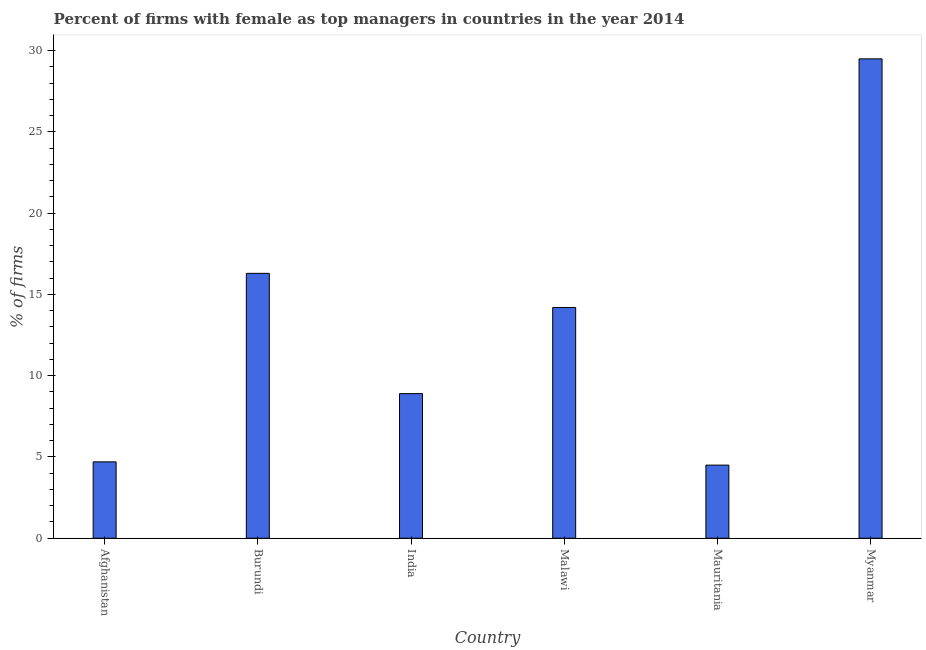What is the title of the graph?
Keep it short and to the point. Percent of firms with female as top managers in countries in the year 2014. What is the label or title of the Y-axis?
Provide a short and direct response. % of firms. What is the percentage of firms with female as top manager in Myanmar?
Your answer should be very brief. 29.5. Across all countries, what is the maximum percentage of firms with female as top manager?
Provide a short and direct response. 29.5. In which country was the percentage of firms with female as top manager maximum?
Your answer should be compact. Myanmar. In which country was the percentage of firms with female as top manager minimum?
Ensure brevity in your answer.  Mauritania. What is the sum of the percentage of firms with female as top manager?
Make the answer very short. 78.1. What is the average percentage of firms with female as top manager per country?
Offer a very short reply. 13.02. What is the median percentage of firms with female as top manager?
Make the answer very short. 11.55. What is the ratio of the percentage of firms with female as top manager in India to that in Malawi?
Give a very brief answer. 0.63. Is the percentage of firms with female as top manager in Burundi less than that in Myanmar?
Provide a short and direct response. Yes. Is the difference between the percentage of firms with female as top manager in India and Malawi greater than the difference between any two countries?
Your response must be concise. No. What is the difference between the highest and the second highest percentage of firms with female as top manager?
Offer a very short reply. 13.2. Is the sum of the percentage of firms with female as top manager in Afghanistan and Burundi greater than the maximum percentage of firms with female as top manager across all countries?
Provide a short and direct response. No. How many countries are there in the graph?
Your response must be concise. 6. What is the difference between two consecutive major ticks on the Y-axis?
Keep it short and to the point. 5. Are the values on the major ticks of Y-axis written in scientific E-notation?
Your answer should be very brief. No. What is the % of firms in Afghanistan?
Your answer should be compact. 4.7. What is the % of firms of Mauritania?
Offer a very short reply. 4.5. What is the % of firms in Myanmar?
Give a very brief answer. 29.5. What is the difference between the % of firms in Afghanistan and Burundi?
Make the answer very short. -11.6. What is the difference between the % of firms in Afghanistan and India?
Your response must be concise. -4.2. What is the difference between the % of firms in Afghanistan and Mauritania?
Offer a very short reply. 0.2. What is the difference between the % of firms in Afghanistan and Myanmar?
Ensure brevity in your answer.  -24.8. What is the difference between the % of firms in Burundi and India?
Give a very brief answer. 7.4. What is the difference between the % of firms in Burundi and Mauritania?
Provide a short and direct response. 11.8. What is the difference between the % of firms in Burundi and Myanmar?
Your answer should be very brief. -13.2. What is the difference between the % of firms in India and Malawi?
Your response must be concise. -5.3. What is the difference between the % of firms in India and Mauritania?
Ensure brevity in your answer.  4.4. What is the difference between the % of firms in India and Myanmar?
Offer a terse response. -20.6. What is the difference between the % of firms in Malawi and Myanmar?
Give a very brief answer. -15.3. What is the ratio of the % of firms in Afghanistan to that in Burundi?
Your answer should be compact. 0.29. What is the ratio of the % of firms in Afghanistan to that in India?
Keep it short and to the point. 0.53. What is the ratio of the % of firms in Afghanistan to that in Malawi?
Keep it short and to the point. 0.33. What is the ratio of the % of firms in Afghanistan to that in Mauritania?
Your response must be concise. 1.04. What is the ratio of the % of firms in Afghanistan to that in Myanmar?
Provide a succinct answer. 0.16. What is the ratio of the % of firms in Burundi to that in India?
Your answer should be compact. 1.83. What is the ratio of the % of firms in Burundi to that in Malawi?
Give a very brief answer. 1.15. What is the ratio of the % of firms in Burundi to that in Mauritania?
Your answer should be compact. 3.62. What is the ratio of the % of firms in Burundi to that in Myanmar?
Make the answer very short. 0.55. What is the ratio of the % of firms in India to that in Malawi?
Your answer should be very brief. 0.63. What is the ratio of the % of firms in India to that in Mauritania?
Your response must be concise. 1.98. What is the ratio of the % of firms in India to that in Myanmar?
Offer a terse response. 0.3. What is the ratio of the % of firms in Malawi to that in Mauritania?
Provide a succinct answer. 3.16. What is the ratio of the % of firms in Malawi to that in Myanmar?
Keep it short and to the point. 0.48. What is the ratio of the % of firms in Mauritania to that in Myanmar?
Make the answer very short. 0.15. 